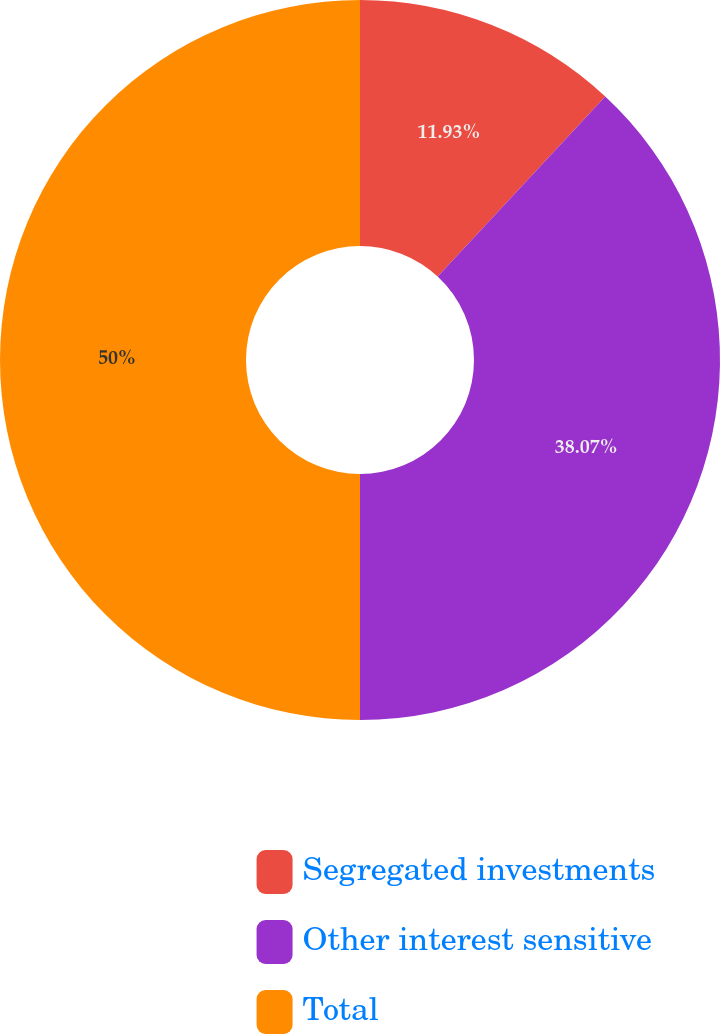Convert chart. <chart><loc_0><loc_0><loc_500><loc_500><pie_chart><fcel>Segregated investments<fcel>Other interest sensitive<fcel>Total<nl><fcel>11.93%<fcel>38.07%<fcel>50.0%<nl></chart> 